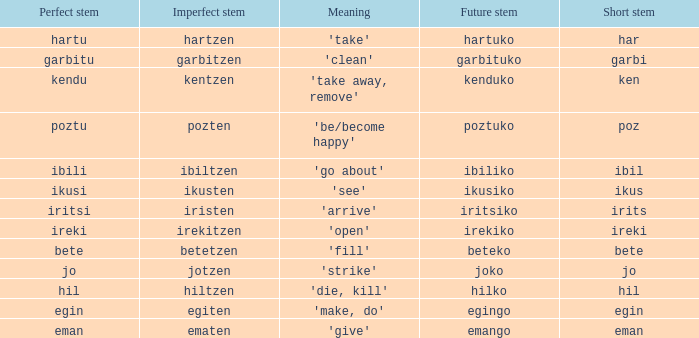What is the perfect stem for pozten? Poztu. 